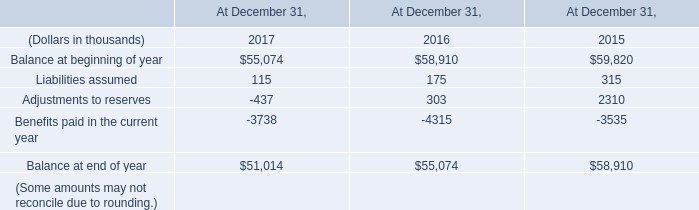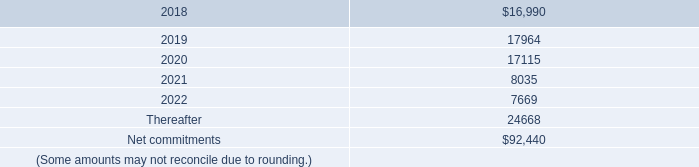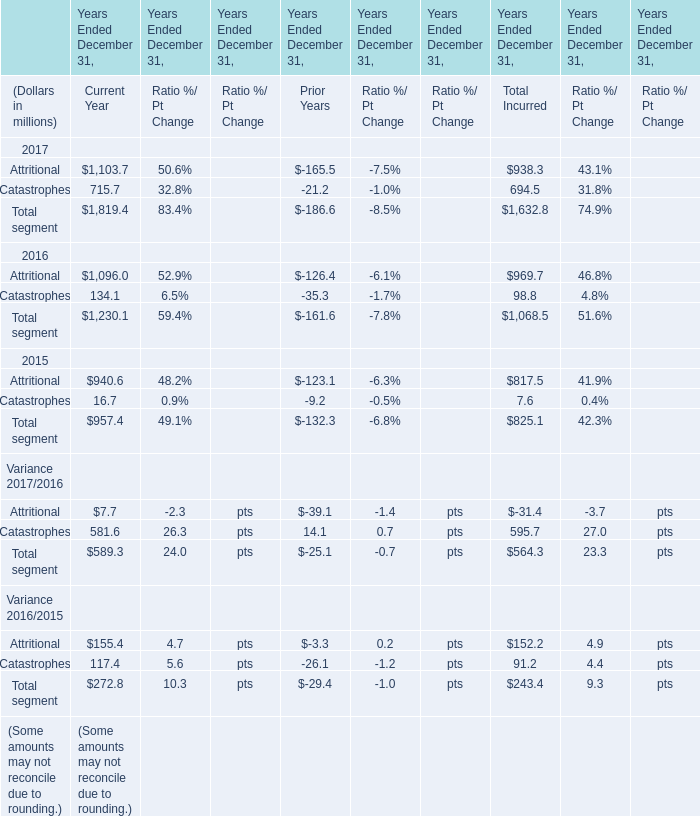What's the total value of all Net income that are smaller than 2000 in 2017 ? (in million) 
Computations: ((1819.4 - 186.6) + 1632.8)
Answer: 3265.6. 